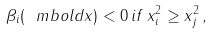<formula> <loc_0><loc_0><loc_500><loc_500>\beta _ { i } ( \ m b o l d { x } ) < 0 \, i f \, x _ { i } ^ { 2 } \geq x _ { j } ^ { 2 } \, ,</formula> 